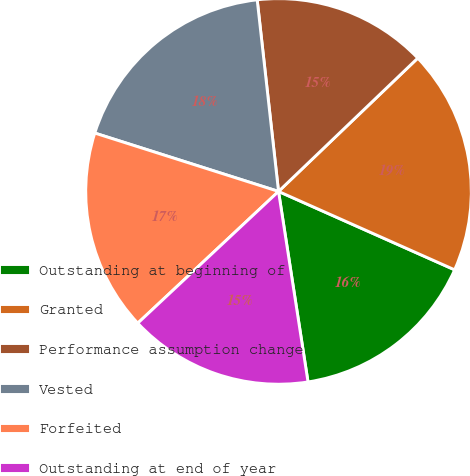Convert chart. <chart><loc_0><loc_0><loc_500><loc_500><pie_chart><fcel>Outstanding at beginning of<fcel>Granted<fcel>Performance assumption change<fcel>Vested<fcel>Forfeited<fcel>Outstanding at end of year<nl><fcel>15.89%<fcel>18.82%<fcel>14.61%<fcel>18.34%<fcel>16.87%<fcel>15.47%<nl></chart> 